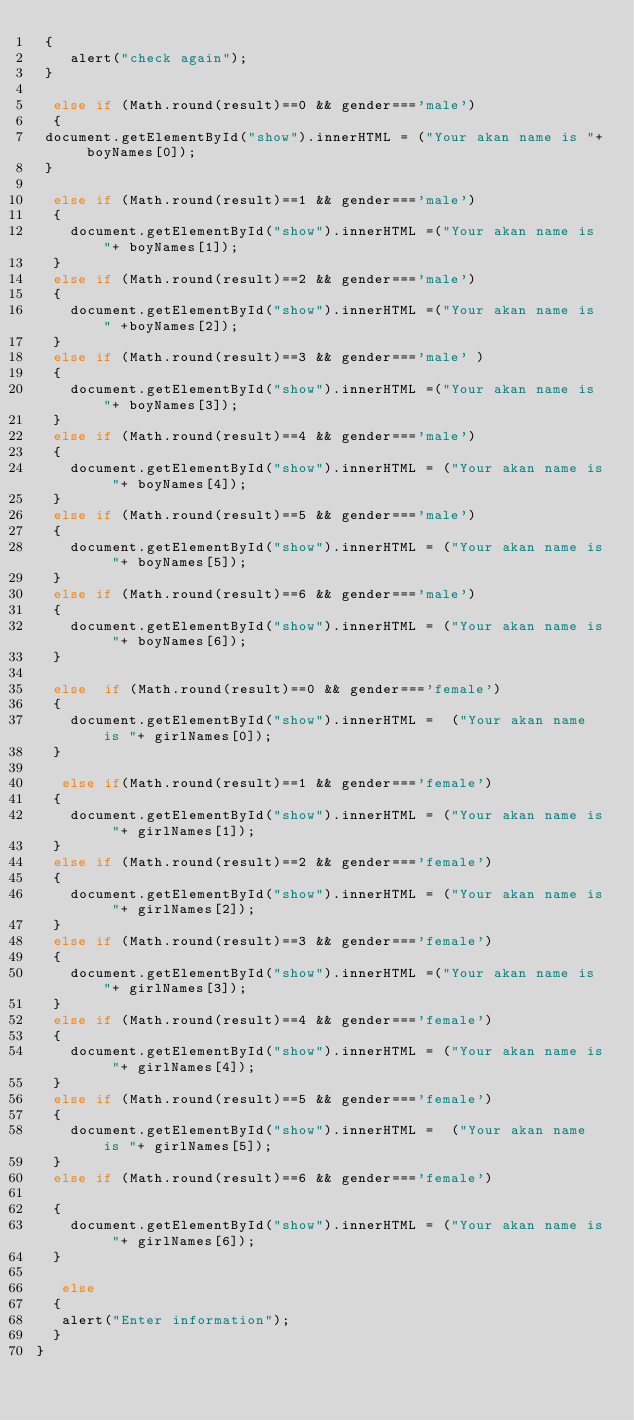Convert code to text. <code><loc_0><loc_0><loc_500><loc_500><_JavaScript_> {
    alert("check again");
 }
 
  else if (Math.round(result)==0 && gender==='male')
  {
 document.getElementById("show").innerHTML = ("Your akan name is "+ boyNames[0]);
 }
 
  else if (Math.round(result)==1 && gender==='male')
  {
    document.getElementById("show").innerHTML =("Your akan name is "+ boyNames[1]);
  }
  else if (Math.round(result)==2 && gender==='male')
  {
    document.getElementById("show").innerHTML =("Your akan name is " +boyNames[2]);
  }
  else if (Math.round(result)==3 && gender==='male' )
  {
    document.getElementById("show").innerHTML =("Your akan name is "+ boyNames[3]);
  }
  else if (Math.round(result)==4 && gender==='male')
  {
    document.getElementById("show").innerHTML = ("Your akan name is "+ boyNames[4]);
  }
  else if (Math.round(result)==5 && gender==='male')
  {
    document.getElementById("show").innerHTML = ("Your akan name is "+ boyNames[5]);
  }
  else if (Math.round(result)==6 && gender==='male')
  {
    document.getElementById("show").innerHTML = ("Your akan name is "+ boyNames[6]);
  }

  else  if (Math.round(result)==0 && gender==='female')
  {
    document.getElementById("show").innerHTML =  ("Your akan name is "+ girlNames[0]);
  }
 
   else if(Math.round(result)==1 && gender==='female')
  {
    document.getElementById("show").innerHTML = ("Your akan name is "+ girlNames[1]);
  }
  else if (Math.round(result)==2 && gender==='female')
  {
    document.getElementById("show").innerHTML = ("Your akan name is "+ girlNames[2]);
  }
  else if (Math.round(result)==3 && gender==='female')
  {
    document.getElementById("show").innerHTML =("Your akan name is "+ girlNames[3]);
  }
  else if (Math.round(result)==4 && gender==='female')
  {
    document.getElementById("show").innerHTML = ("Your akan name is "+ girlNames[4]);
  }
  else if (Math.round(result)==5 && gender==='female')
  {
    document.getElementById("show").innerHTML =  ("Your akan name is "+ girlNames[5]);
  }
  else if (Math.round(result)==6 && gender==='female')
  
  {
    document.getElementById("show").innerHTML = ("Your akan name is "+ girlNames[6]);
  }
  
   else
  {
   alert("Enter information");
  }
}</code> 